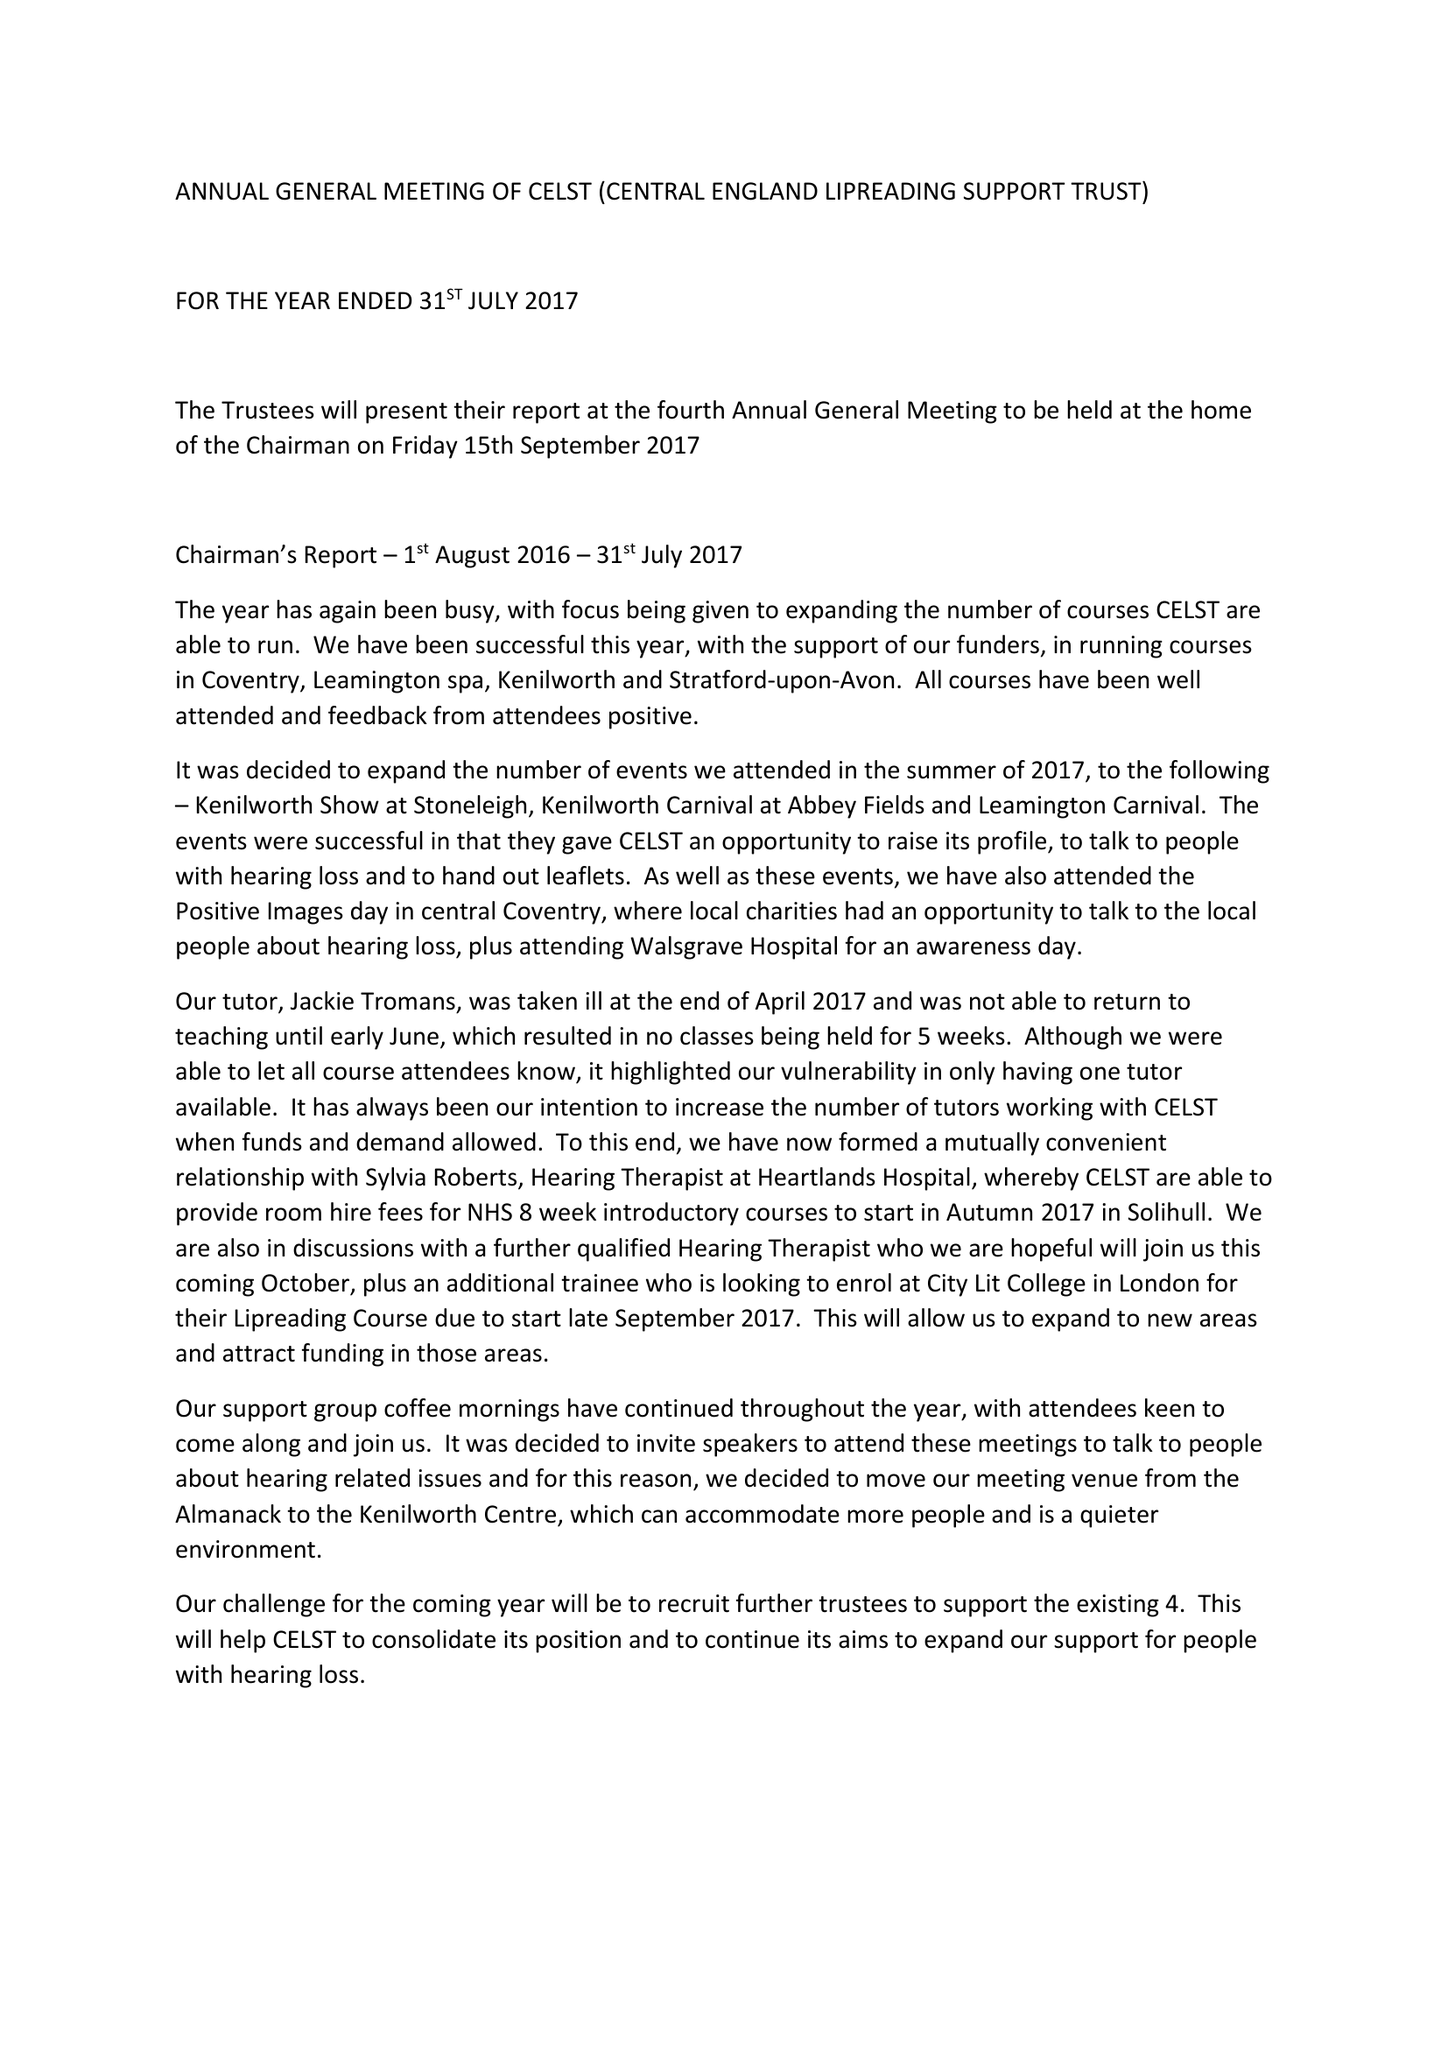What is the value for the charity_name?
Answer the question using a single word or phrase. Central England Lipreading Support Trust 